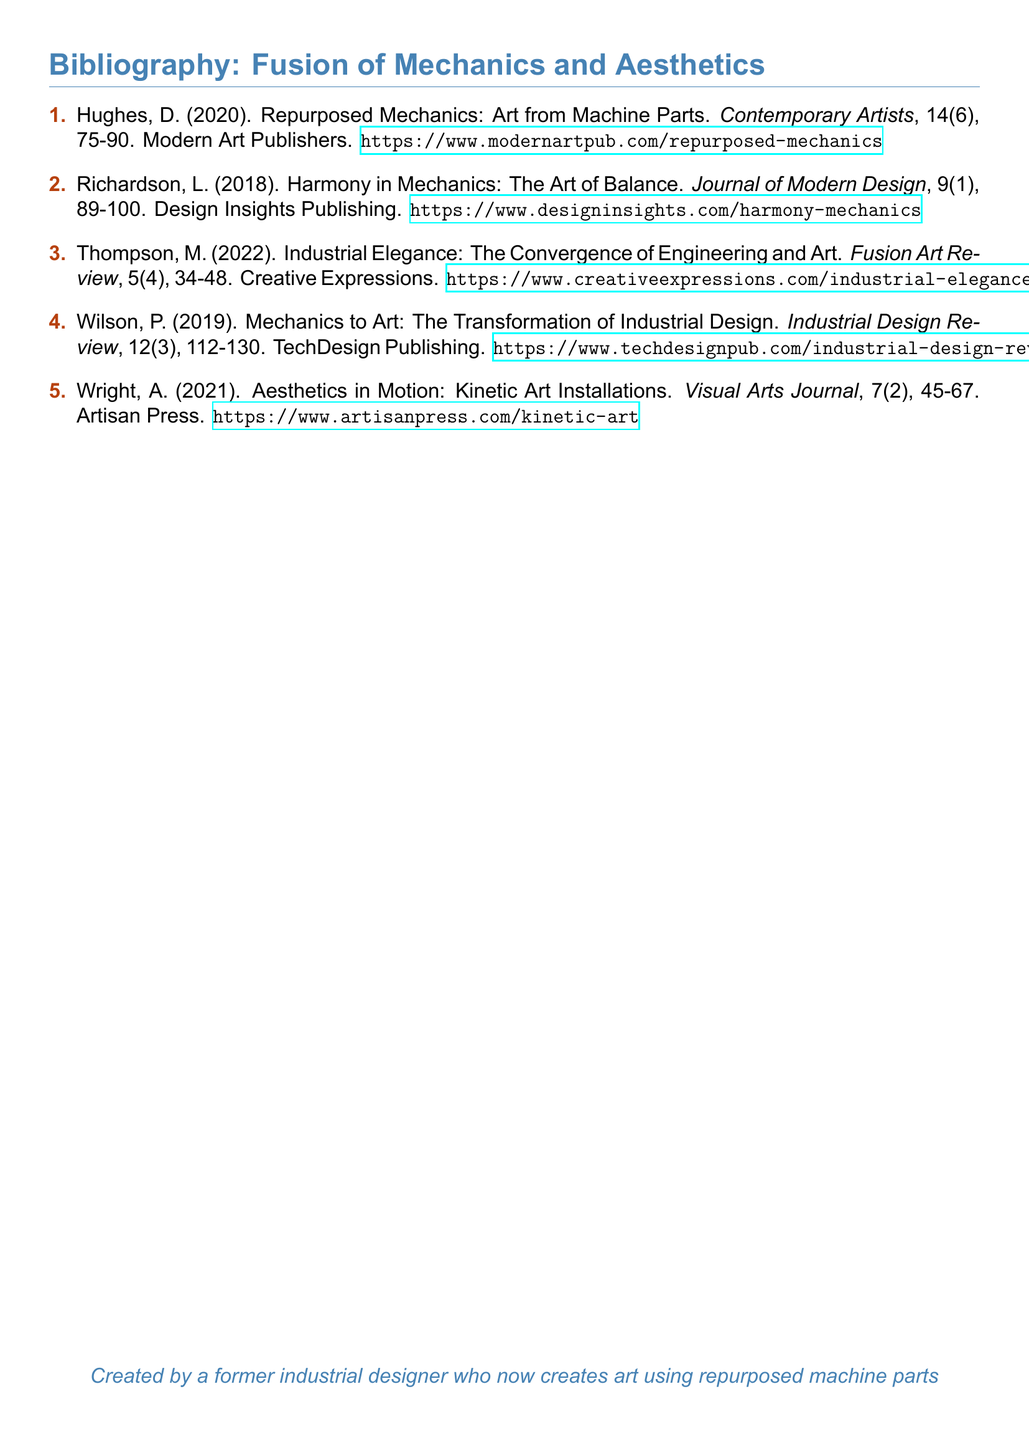What is the title of the first item in the bibliography? The title of the first item is "Repurposed Mechanics: Art from Machine Parts."
Answer: Repurposed Mechanics: Art from Machine Parts What year was the article by Thompson published? The article by Thompson was published in 2022.
Answer: 2022 Who published the article "Harmony in Mechanics: The Art of Balance"? The article was published by Design Insights Publishing.
Answer: Design Insights Publishing What is the volume number for "Visual Arts Journal"? The volume number for "Visual Arts Journal" is 7.
Answer: 7 How many items are listed in the bibliography? There are a total of five items listed.
Answer: 5 Which article focuses on kinetic art? The article that focuses on kinetic art is "Aesthetics in Motion: Kinetic Art Installations."
Answer: Aesthetics in Motion: Kinetic Art Installations Which author's work discusses the transformation of industrial design? The author's work discussing the transformation is by Wilson.
Answer: Wilson What is the journal name for the item authored by Wright? The journal name for the item authored by Wright is "Visual Arts Journal."
Answer: Visual Arts Journal 